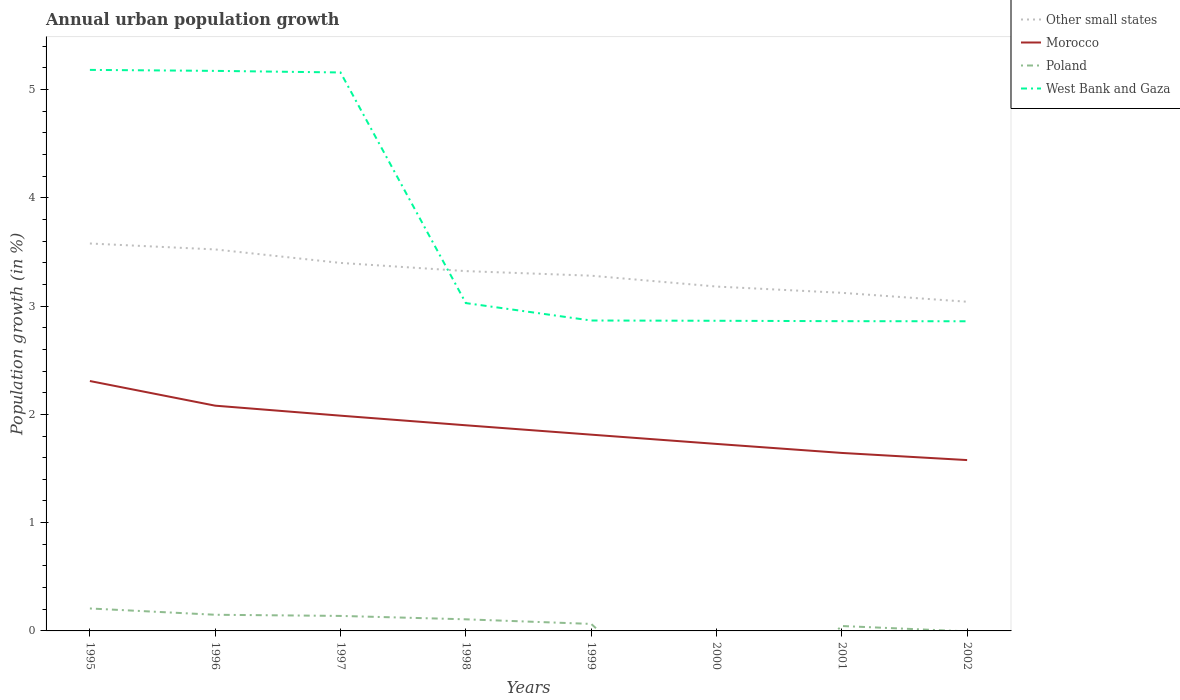Is the number of lines equal to the number of legend labels?
Keep it short and to the point. No. What is the total percentage of urban population growth in Morocco in the graph?
Your answer should be very brief. 0.26. What is the difference between the highest and the second highest percentage of urban population growth in Poland?
Provide a short and direct response. 0.21. Is the percentage of urban population growth in Poland strictly greater than the percentage of urban population growth in West Bank and Gaza over the years?
Keep it short and to the point. Yes. How many years are there in the graph?
Provide a succinct answer. 8. What is the difference between two consecutive major ticks on the Y-axis?
Your answer should be compact. 1. Are the values on the major ticks of Y-axis written in scientific E-notation?
Ensure brevity in your answer.  No. Does the graph contain any zero values?
Your answer should be compact. Yes. How many legend labels are there?
Your response must be concise. 4. How are the legend labels stacked?
Offer a very short reply. Vertical. What is the title of the graph?
Ensure brevity in your answer.  Annual urban population growth. Does "Argentina" appear as one of the legend labels in the graph?
Your response must be concise. No. What is the label or title of the Y-axis?
Give a very brief answer. Population growth (in %). What is the Population growth (in %) of Other small states in 1995?
Your answer should be compact. 3.58. What is the Population growth (in %) in Morocco in 1995?
Your answer should be compact. 2.31. What is the Population growth (in %) in Poland in 1995?
Provide a succinct answer. 0.21. What is the Population growth (in %) in West Bank and Gaza in 1995?
Give a very brief answer. 5.18. What is the Population growth (in %) of Other small states in 1996?
Your answer should be compact. 3.52. What is the Population growth (in %) of Morocco in 1996?
Keep it short and to the point. 2.08. What is the Population growth (in %) of Poland in 1996?
Keep it short and to the point. 0.15. What is the Population growth (in %) in West Bank and Gaza in 1996?
Offer a very short reply. 5.17. What is the Population growth (in %) of Other small states in 1997?
Provide a succinct answer. 3.4. What is the Population growth (in %) of Morocco in 1997?
Offer a very short reply. 1.99. What is the Population growth (in %) in Poland in 1997?
Make the answer very short. 0.14. What is the Population growth (in %) of West Bank and Gaza in 1997?
Your response must be concise. 5.16. What is the Population growth (in %) in Other small states in 1998?
Ensure brevity in your answer.  3.32. What is the Population growth (in %) of Morocco in 1998?
Keep it short and to the point. 1.9. What is the Population growth (in %) in Poland in 1998?
Offer a terse response. 0.11. What is the Population growth (in %) of West Bank and Gaza in 1998?
Your answer should be compact. 3.03. What is the Population growth (in %) in Other small states in 1999?
Provide a short and direct response. 3.28. What is the Population growth (in %) in Morocco in 1999?
Your answer should be compact. 1.81. What is the Population growth (in %) of Poland in 1999?
Your answer should be compact. 0.06. What is the Population growth (in %) of West Bank and Gaza in 1999?
Provide a succinct answer. 2.87. What is the Population growth (in %) of Other small states in 2000?
Offer a terse response. 3.18. What is the Population growth (in %) of Morocco in 2000?
Your response must be concise. 1.73. What is the Population growth (in %) of West Bank and Gaza in 2000?
Offer a very short reply. 2.86. What is the Population growth (in %) of Other small states in 2001?
Your answer should be very brief. 3.12. What is the Population growth (in %) in Morocco in 2001?
Provide a short and direct response. 1.64. What is the Population growth (in %) of Poland in 2001?
Make the answer very short. 0.05. What is the Population growth (in %) in West Bank and Gaza in 2001?
Keep it short and to the point. 2.86. What is the Population growth (in %) in Other small states in 2002?
Ensure brevity in your answer.  3.04. What is the Population growth (in %) of Morocco in 2002?
Offer a terse response. 1.58. What is the Population growth (in %) of West Bank and Gaza in 2002?
Offer a very short reply. 2.86. Across all years, what is the maximum Population growth (in %) in Other small states?
Provide a succinct answer. 3.58. Across all years, what is the maximum Population growth (in %) of Morocco?
Offer a very short reply. 2.31. Across all years, what is the maximum Population growth (in %) of Poland?
Your answer should be compact. 0.21. Across all years, what is the maximum Population growth (in %) in West Bank and Gaza?
Your response must be concise. 5.18. Across all years, what is the minimum Population growth (in %) of Other small states?
Your answer should be very brief. 3.04. Across all years, what is the minimum Population growth (in %) of Morocco?
Your answer should be compact. 1.58. Across all years, what is the minimum Population growth (in %) of Poland?
Your answer should be compact. 0. Across all years, what is the minimum Population growth (in %) in West Bank and Gaza?
Provide a short and direct response. 2.86. What is the total Population growth (in %) of Other small states in the graph?
Make the answer very short. 26.44. What is the total Population growth (in %) of Morocco in the graph?
Offer a terse response. 15.04. What is the total Population growth (in %) of Poland in the graph?
Offer a very short reply. 0.71. What is the total Population growth (in %) of West Bank and Gaza in the graph?
Your answer should be compact. 29.99. What is the difference between the Population growth (in %) of Other small states in 1995 and that in 1996?
Your answer should be very brief. 0.05. What is the difference between the Population growth (in %) of Morocco in 1995 and that in 1996?
Your response must be concise. 0.23. What is the difference between the Population growth (in %) in Poland in 1995 and that in 1996?
Give a very brief answer. 0.06. What is the difference between the Population growth (in %) in West Bank and Gaza in 1995 and that in 1996?
Ensure brevity in your answer.  0.01. What is the difference between the Population growth (in %) in Other small states in 1995 and that in 1997?
Ensure brevity in your answer.  0.18. What is the difference between the Population growth (in %) in Morocco in 1995 and that in 1997?
Make the answer very short. 0.32. What is the difference between the Population growth (in %) of Poland in 1995 and that in 1997?
Your response must be concise. 0.07. What is the difference between the Population growth (in %) in West Bank and Gaza in 1995 and that in 1997?
Offer a terse response. 0.02. What is the difference between the Population growth (in %) of Other small states in 1995 and that in 1998?
Ensure brevity in your answer.  0.25. What is the difference between the Population growth (in %) of Morocco in 1995 and that in 1998?
Your answer should be compact. 0.41. What is the difference between the Population growth (in %) of Poland in 1995 and that in 1998?
Provide a short and direct response. 0.1. What is the difference between the Population growth (in %) of West Bank and Gaza in 1995 and that in 1998?
Provide a short and direct response. 2.15. What is the difference between the Population growth (in %) in Other small states in 1995 and that in 1999?
Offer a very short reply. 0.3. What is the difference between the Population growth (in %) in Morocco in 1995 and that in 1999?
Offer a terse response. 0.5. What is the difference between the Population growth (in %) of Poland in 1995 and that in 1999?
Provide a succinct answer. 0.14. What is the difference between the Population growth (in %) in West Bank and Gaza in 1995 and that in 1999?
Keep it short and to the point. 2.31. What is the difference between the Population growth (in %) of Other small states in 1995 and that in 2000?
Offer a terse response. 0.4. What is the difference between the Population growth (in %) of Morocco in 1995 and that in 2000?
Make the answer very short. 0.58. What is the difference between the Population growth (in %) of West Bank and Gaza in 1995 and that in 2000?
Your answer should be very brief. 2.32. What is the difference between the Population growth (in %) of Other small states in 1995 and that in 2001?
Offer a terse response. 0.46. What is the difference between the Population growth (in %) of Morocco in 1995 and that in 2001?
Offer a terse response. 0.66. What is the difference between the Population growth (in %) of Poland in 1995 and that in 2001?
Keep it short and to the point. 0.16. What is the difference between the Population growth (in %) in West Bank and Gaza in 1995 and that in 2001?
Your answer should be very brief. 2.32. What is the difference between the Population growth (in %) of Other small states in 1995 and that in 2002?
Offer a terse response. 0.54. What is the difference between the Population growth (in %) of Morocco in 1995 and that in 2002?
Offer a very short reply. 0.73. What is the difference between the Population growth (in %) in West Bank and Gaza in 1995 and that in 2002?
Keep it short and to the point. 2.32. What is the difference between the Population growth (in %) of Other small states in 1996 and that in 1997?
Make the answer very short. 0.12. What is the difference between the Population growth (in %) of Morocco in 1996 and that in 1997?
Keep it short and to the point. 0.09. What is the difference between the Population growth (in %) in Poland in 1996 and that in 1997?
Give a very brief answer. 0.01. What is the difference between the Population growth (in %) of West Bank and Gaza in 1996 and that in 1997?
Offer a terse response. 0.01. What is the difference between the Population growth (in %) of Other small states in 1996 and that in 1998?
Give a very brief answer. 0.2. What is the difference between the Population growth (in %) in Morocco in 1996 and that in 1998?
Give a very brief answer. 0.18. What is the difference between the Population growth (in %) in Poland in 1996 and that in 1998?
Keep it short and to the point. 0.04. What is the difference between the Population growth (in %) of West Bank and Gaza in 1996 and that in 1998?
Provide a succinct answer. 2.14. What is the difference between the Population growth (in %) of Other small states in 1996 and that in 1999?
Offer a terse response. 0.24. What is the difference between the Population growth (in %) of Morocco in 1996 and that in 1999?
Ensure brevity in your answer.  0.27. What is the difference between the Population growth (in %) of Poland in 1996 and that in 1999?
Make the answer very short. 0.08. What is the difference between the Population growth (in %) of West Bank and Gaza in 1996 and that in 1999?
Keep it short and to the point. 2.31. What is the difference between the Population growth (in %) of Other small states in 1996 and that in 2000?
Your answer should be compact. 0.34. What is the difference between the Population growth (in %) of Morocco in 1996 and that in 2000?
Your response must be concise. 0.35. What is the difference between the Population growth (in %) in West Bank and Gaza in 1996 and that in 2000?
Offer a terse response. 2.31. What is the difference between the Population growth (in %) in Other small states in 1996 and that in 2001?
Your answer should be compact. 0.4. What is the difference between the Population growth (in %) of Morocco in 1996 and that in 2001?
Ensure brevity in your answer.  0.44. What is the difference between the Population growth (in %) of Poland in 1996 and that in 2001?
Provide a succinct answer. 0.1. What is the difference between the Population growth (in %) in West Bank and Gaza in 1996 and that in 2001?
Your answer should be compact. 2.31. What is the difference between the Population growth (in %) of Other small states in 1996 and that in 2002?
Offer a very short reply. 0.48. What is the difference between the Population growth (in %) of Morocco in 1996 and that in 2002?
Your answer should be compact. 0.5. What is the difference between the Population growth (in %) in West Bank and Gaza in 1996 and that in 2002?
Make the answer very short. 2.31. What is the difference between the Population growth (in %) of Other small states in 1997 and that in 1998?
Your answer should be compact. 0.08. What is the difference between the Population growth (in %) in Morocco in 1997 and that in 1998?
Offer a very short reply. 0.09. What is the difference between the Population growth (in %) in Poland in 1997 and that in 1998?
Give a very brief answer. 0.03. What is the difference between the Population growth (in %) in West Bank and Gaza in 1997 and that in 1998?
Provide a succinct answer. 2.13. What is the difference between the Population growth (in %) in Other small states in 1997 and that in 1999?
Provide a short and direct response. 0.12. What is the difference between the Population growth (in %) in Morocco in 1997 and that in 1999?
Your response must be concise. 0.18. What is the difference between the Population growth (in %) in Poland in 1997 and that in 1999?
Make the answer very short. 0.07. What is the difference between the Population growth (in %) in West Bank and Gaza in 1997 and that in 1999?
Give a very brief answer. 2.29. What is the difference between the Population growth (in %) in Other small states in 1997 and that in 2000?
Keep it short and to the point. 0.22. What is the difference between the Population growth (in %) in Morocco in 1997 and that in 2000?
Offer a terse response. 0.26. What is the difference between the Population growth (in %) in West Bank and Gaza in 1997 and that in 2000?
Your answer should be very brief. 2.29. What is the difference between the Population growth (in %) of Other small states in 1997 and that in 2001?
Ensure brevity in your answer.  0.28. What is the difference between the Population growth (in %) of Morocco in 1997 and that in 2001?
Ensure brevity in your answer.  0.34. What is the difference between the Population growth (in %) in Poland in 1997 and that in 2001?
Provide a short and direct response. 0.09. What is the difference between the Population growth (in %) in West Bank and Gaza in 1997 and that in 2001?
Your answer should be very brief. 2.3. What is the difference between the Population growth (in %) in Other small states in 1997 and that in 2002?
Provide a succinct answer. 0.36. What is the difference between the Population growth (in %) in Morocco in 1997 and that in 2002?
Your answer should be compact. 0.41. What is the difference between the Population growth (in %) in West Bank and Gaza in 1997 and that in 2002?
Make the answer very short. 2.3. What is the difference between the Population growth (in %) of Other small states in 1998 and that in 1999?
Make the answer very short. 0.04. What is the difference between the Population growth (in %) in Morocco in 1998 and that in 1999?
Provide a succinct answer. 0.09. What is the difference between the Population growth (in %) of Poland in 1998 and that in 1999?
Your answer should be compact. 0.04. What is the difference between the Population growth (in %) of West Bank and Gaza in 1998 and that in 1999?
Your answer should be very brief. 0.16. What is the difference between the Population growth (in %) of Other small states in 1998 and that in 2000?
Provide a succinct answer. 0.14. What is the difference between the Population growth (in %) of Morocco in 1998 and that in 2000?
Provide a succinct answer. 0.17. What is the difference between the Population growth (in %) of West Bank and Gaza in 1998 and that in 2000?
Your answer should be very brief. 0.16. What is the difference between the Population growth (in %) in Other small states in 1998 and that in 2001?
Offer a terse response. 0.2. What is the difference between the Population growth (in %) of Morocco in 1998 and that in 2001?
Offer a terse response. 0.26. What is the difference between the Population growth (in %) in Poland in 1998 and that in 2001?
Provide a succinct answer. 0.06. What is the difference between the Population growth (in %) of West Bank and Gaza in 1998 and that in 2001?
Offer a terse response. 0.17. What is the difference between the Population growth (in %) of Other small states in 1998 and that in 2002?
Provide a short and direct response. 0.28. What is the difference between the Population growth (in %) in Morocco in 1998 and that in 2002?
Keep it short and to the point. 0.32. What is the difference between the Population growth (in %) in West Bank and Gaza in 1998 and that in 2002?
Your answer should be compact. 0.17. What is the difference between the Population growth (in %) in Other small states in 1999 and that in 2000?
Keep it short and to the point. 0.1. What is the difference between the Population growth (in %) of Morocco in 1999 and that in 2000?
Your answer should be compact. 0.09. What is the difference between the Population growth (in %) of West Bank and Gaza in 1999 and that in 2000?
Give a very brief answer. 0. What is the difference between the Population growth (in %) of Other small states in 1999 and that in 2001?
Your answer should be very brief. 0.16. What is the difference between the Population growth (in %) of Morocco in 1999 and that in 2001?
Your response must be concise. 0.17. What is the difference between the Population growth (in %) in Poland in 1999 and that in 2001?
Your answer should be compact. 0.02. What is the difference between the Population growth (in %) in West Bank and Gaza in 1999 and that in 2001?
Offer a very short reply. 0.01. What is the difference between the Population growth (in %) in Other small states in 1999 and that in 2002?
Give a very brief answer. 0.24. What is the difference between the Population growth (in %) in Morocco in 1999 and that in 2002?
Offer a terse response. 0.23. What is the difference between the Population growth (in %) of West Bank and Gaza in 1999 and that in 2002?
Provide a short and direct response. 0.01. What is the difference between the Population growth (in %) in Other small states in 2000 and that in 2001?
Provide a short and direct response. 0.06. What is the difference between the Population growth (in %) of Morocco in 2000 and that in 2001?
Offer a very short reply. 0.08. What is the difference between the Population growth (in %) in West Bank and Gaza in 2000 and that in 2001?
Ensure brevity in your answer.  0. What is the difference between the Population growth (in %) in Other small states in 2000 and that in 2002?
Your response must be concise. 0.14. What is the difference between the Population growth (in %) of Morocco in 2000 and that in 2002?
Keep it short and to the point. 0.15. What is the difference between the Population growth (in %) of West Bank and Gaza in 2000 and that in 2002?
Ensure brevity in your answer.  0. What is the difference between the Population growth (in %) of Other small states in 2001 and that in 2002?
Make the answer very short. 0.08. What is the difference between the Population growth (in %) in Morocco in 2001 and that in 2002?
Your response must be concise. 0.07. What is the difference between the Population growth (in %) in West Bank and Gaza in 2001 and that in 2002?
Your answer should be very brief. 0. What is the difference between the Population growth (in %) in Other small states in 1995 and the Population growth (in %) in Morocco in 1996?
Give a very brief answer. 1.5. What is the difference between the Population growth (in %) of Other small states in 1995 and the Population growth (in %) of Poland in 1996?
Your response must be concise. 3.43. What is the difference between the Population growth (in %) in Other small states in 1995 and the Population growth (in %) in West Bank and Gaza in 1996?
Give a very brief answer. -1.59. What is the difference between the Population growth (in %) of Morocco in 1995 and the Population growth (in %) of Poland in 1996?
Keep it short and to the point. 2.16. What is the difference between the Population growth (in %) in Morocco in 1995 and the Population growth (in %) in West Bank and Gaza in 1996?
Offer a very short reply. -2.86. What is the difference between the Population growth (in %) of Poland in 1995 and the Population growth (in %) of West Bank and Gaza in 1996?
Offer a terse response. -4.96. What is the difference between the Population growth (in %) in Other small states in 1995 and the Population growth (in %) in Morocco in 1997?
Keep it short and to the point. 1.59. What is the difference between the Population growth (in %) of Other small states in 1995 and the Population growth (in %) of Poland in 1997?
Offer a terse response. 3.44. What is the difference between the Population growth (in %) of Other small states in 1995 and the Population growth (in %) of West Bank and Gaza in 1997?
Ensure brevity in your answer.  -1.58. What is the difference between the Population growth (in %) in Morocco in 1995 and the Population growth (in %) in Poland in 1997?
Your answer should be very brief. 2.17. What is the difference between the Population growth (in %) of Morocco in 1995 and the Population growth (in %) of West Bank and Gaza in 1997?
Provide a short and direct response. -2.85. What is the difference between the Population growth (in %) of Poland in 1995 and the Population growth (in %) of West Bank and Gaza in 1997?
Provide a short and direct response. -4.95. What is the difference between the Population growth (in %) of Other small states in 1995 and the Population growth (in %) of Morocco in 1998?
Give a very brief answer. 1.68. What is the difference between the Population growth (in %) of Other small states in 1995 and the Population growth (in %) of Poland in 1998?
Your answer should be compact. 3.47. What is the difference between the Population growth (in %) in Other small states in 1995 and the Population growth (in %) in West Bank and Gaza in 1998?
Your answer should be compact. 0.55. What is the difference between the Population growth (in %) of Morocco in 1995 and the Population growth (in %) of Poland in 1998?
Offer a terse response. 2.2. What is the difference between the Population growth (in %) of Morocco in 1995 and the Population growth (in %) of West Bank and Gaza in 1998?
Offer a terse response. -0.72. What is the difference between the Population growth (in %) of Poland in 1995 and the Population growth (in %) of West Bank and Gaza in 1998?
Make the answer very short. -2.82. What is the difference between the Population growth (in %) in Other small states in 1995 and the Population growth (in %) in Morocco in 1999?
Offer a terse response. 1.77. What is the difference between the Population growth (in %) in Other small states in 1995 and the Population growth (in %) in Poland in 1999?
Your response must be concise. 3.51. What is the difference between the Population growth (in %) in Other small states in 1995 and the Population growth (in %) in West Bank and Gaza in 1999?
Provide a short and direct response. 0.71. What is the difference between the Population growth (in %) of Morocco in 1995 and the Population growth (in %) of Poland in 1999?
Give a very brief answer. 2.24. What is the difference between the Population growth (in %) of Morocco in 1995 and the Population growth (in %) of West Bank and Gaza in 1999?
Give a very brief answer. -0.56. What is the difference between the Population growth (in %) of Poland in 1995 and the Population growth (in %) of West Bank and Gaza in 1999?
Ensure brevity in your answer.  -2.66. What is the difference between the Population growth (in %) of Other small states in 1995 and the Population growth (in %) of Morocco in 2000?
Your answer should be very brief. 1.85. What is the difference between the Population growth (in %) of Other small states in 1995 and the Population growth (in %) of West Bank and Gaza in 2000?
Offer a very short reply. 0.71. What is the difference between the Population growth (in %) of Morocco in 1995 and the Population growth (in %) of West Bank and Gaza in 2000?
Provide a short and direct response. -0.56. What is the difference between the Population growth (in %) of Poland in 1995 and the Population growth (in %) of West Bank and Gaza in 2000?
Ensure brevity in your answer.  -2.66. What is the difference between the Population growth (in %) of Other small states in 1995 and the Population growth (in %) of Morocco in 2001?
Your response must be concise. 1.93. What is the difference between the Population growth (in %) of Other small states in 1995 and the Population growth (in %) of Poland in 2001?
Make the answer very short. 3.53. What is the difference between the Population growth (in %) of Other small states in 1995 and the Population growth (in %) of West Bank and Gaza in 2001?
Offer a terse response. 0.72. What is the difference between the Population growth (in %) of Morocco in 1995 and the Population growth (in %) of Poland in 2001?
Offer a very short reply. 2.26. What is the difference between the Population growth (in %) of Morocco in 1995 and the Population growth (in %) of West Bank and Gaza in 2001?
Your answer should be very brief. -0.55. What is the difference between the Population growth (in %) in Poland in 1995 and the Population growth (in %) in West Bank and Gaza in 2001?
Your answer should be compact. -2.65. What is the difference between the Population growth (in %) of Other small states in 1995 and the Population growth (in %) of Morocco in 2002?
Provide a short and direct response. 2. What is the difference between the Population growth (in %) of Other small states in 1995 and the Population growth (in %) of West Bank and Gaza in 2002?
Your answer should be compact. 0.72. What is the difference between the Population growth (in %) in Morocco in 1995 and the Population growth (in %) in West Bank and Gaza in 2002?
Offer a very short reply. -0.55. What is the difference between the Population growth (in %) in Poland in 1995 and the Population growth (in %) in West Bank and Gaza in 2002?
Give a very brief answer. -2.65. What is the difference between the Population growth (in %) in Other small states in 1996 and the Population growth (in %) in Morocco in 1997?
Your answer should be compact. 1.54. What is the difference between the Population growth (in %) of Other small states in 1996 and the Population growth (in %) of Poland in 1997?
Give a very brief answer. 3.38. What is the difference between the Population growth (in %) of Other small states in 1996 and the Population growth (in %) of West Bank and Gaza in 1997?
Give a very brief answer. -1.63. What is the difference between the Population growth (in %) of Morocco in 1996 and the Population growth (in %) of Poland in 1997?
Provide a short and direct response. 1.94. What is the difference between the Population growth (in %) in Morocco in 1996 and the Population growth (in %) in West Bank and Gaza in 1997?
Ensure brevity in your answer.  -3.08. What is the difference between the Population growth (in %) in Poland in 1996 and the Population growth (in %) in West Bank and Gaza in 1997?
Offer a very short reply. -5.01. What is the difference between the Population growth (in %) of Other small states in 1996 and the Population growth (in %) of Morocco in 1998?
Your answer should be compact. 1.62. What is the difference between the Population growth (in %) of Other small states in 1996 and the Population growth (in %) of Poland in 1998?
Ensure brevity in your answer.  3.42. What is the difference between the Population growth (in %) in Other small states in 1996 and the Population growth (in %) in West Bank and Gaza in 1998?
Keep it short and to the point. 0.5. What is the difference between the Population growth (in %) in Morocco in 1996 and the Population growth (in %) in Poland in 1998?
Offer a terse response. 1.97. What is the difference between the Population growth (in %) in Morocco in 1996 and the Population growth (in %) in West Bank and Gaza in 1998?
Offer a very short reply. -0.95. What is the difference between the Population growth (in %) in Poland in 1996 and the Population growth (in %) in West Bank and Gaza in 1998?
Give a very brief answer. -2.88. What is the difference between the Population growth (in %) of Other small states in 1996 and the Population growth (in %) of Morocco in 1999?
Provide a short and direct response. 1.71. What is the difference between the Population growth (in %) of Other small states in 1996 and the Population growth (in %) of Poland in 1999?
Give a very brief answer. 3.46. What is the difference between the Population growth (in %) of Other small states in 1996 and the Population growth (in %) of West Bank and Gaza in 1999?
Give a very brief answer. 0.66. What is the difference between the Population growth (in %) in Morocco in 1996 and the Population growth (in %) in Poland in 1999?
Make the answer very short. 2.02. What is the difference between the Population growth (in %) of Morocco in 1996 and the Population growth (in %) of West Bank and Gaza in 1999?
Provide a short and direct response. -0.79. What is the difference between the Population growth (in %) in Poland in 1996 and the Population growth (in %) in West Bank and Gaza in 1999?
Provide a short and direct response. -2.72. What is the difference between the Population growth (in %) of Other small states in 1996 and the Population growth (in %) of Morocco in 2000?
Ensure brevity in your answer.  1.8. What is the difference between the Population growth (in %) of Other small states in 1996 and the Population growth (in %) of West Bank and Gaza in 2000?
Ensure brevity in your answer.  0.66. What is the difference between the Population growth (in %) in Morocco in 1996 and the Population growth (in %) in West Bank and Gaza in 2000?
Your answer should be very brief. -0.78. What is the difference between the Population growth (in %) of Poland in 1996 and the Population growth (in %) of West Bank and Gaza in 2000?
Make the answer very short. -2.71. What is the difference between the Population growth (in %) of Other small states in 1996 and the Population growth (in %) of Morocco in 2001?
Make the answer very short. 1.88. What is the difference between the Population growth (in %) in Other small states in 1996 and the Population growth (in %) in Poland in 2001?
Provide a succinct answer. 3.48. What is the difference between the Population growth (in %) of Other small states in 1996 and the Population growth (in %) of West Bank and Gaza in 2001?
Offer a very short reply. 0.66. What is the difference between the Population growth (in %) in Morocco in 1996 and the Population growth (in %) in Poland in 2001?
Your answer should be compact. 2.03. What is the difference between the Population growth (in %) of Morocco in 1996 and the Population growth (in %) of West Bank and Gaza in 2001?
Offer a terse response. -0.78. What is the difference between the Population growth (in %) of Poland in 1996 and the Population growth (in %) of West Bank and Gaza in 2001?
Make the answer very short. -2.71. What is the difference between the Population growth (in %) of Other small states in 1996 and the Population growth (in %) of Morocco in 2002?
Make the answer very short. 1.95. What is the difference between the Population growth (in %) in Other small states in 1996 and the Population growth (in %) in West Bank and Gaza in 2002?
Offer a very short reply. 0.66. What is the difference between the Population growth (in %) of Morocco in 1996 and the Population growth (in %) of West Bank and Gaza in 2002?
Make the answer very short. -0.78. What is the difference between the Population growth (in %) in Poland in 1996 and the Population growth (in %) in West Bank and Gaza in 2002?
Make the answer very short. -2.71. What is the difference between the Population growth (in %) in Other small states in 1997 and the Population growth (in %) in Morocco in 1998?
Provide a succinct answer. 1.5. What is the difference between the Population growth (in %) in Other small states in 1997 and the Population growth (in %) in Poland in 1998?
Offer a very short reply. 3.29. What is the difference between the Population growth (in %) of Other small states in 1997 and the Population growth (in %) of West Bank and Gaza in 1998?
Provide a succinct answer. 0.37. What is the difference between the Population growth (in %) in Morocco in 1997 and the Population growth (in %) in Poland in 1998?
Your answer should be compact. 1.88. What is the difference between the Population growth (in %) in Morocco in 1997 and the Population growth (in %) in West Bank and Gaza in 1998?
Offer a terse response. -1.04. What is the difference between the Population growth (in %) in Poland in 1997 and the Population growth (in %) in West Bank and Gaza in 1998?
Ensure brevity in your answer.  -2.89. What is the difference between the Population growth (in %) in Other small states in 1997 and the Population growth (in %) in Morocco in 1999?
Ensure brevity in your answer.  1.59. What is the difference between the Population growth (in %) of Other small states in 1997 and the Population growth (in %) of Poland in 1999?
Provide a short and direct response. 3.33. What is the difference between the Population growth (in %) of Other small states in 1997 and the Population growth (in %) of West Bank and Gaza in 1999?
Ensure brevity in your answer.  0.53. What is the difference between the Population growth (in %) in Morocco in 1997 and the Population growth (in %) in Poland in 1999?
Give a very brief answer. 1.92. What is the difference between the Population growth (in %) of Morocco in 1997 and the Population growth (in %) of West Bank and Gaza in 1999?
Provide a short and direct response. -0.88. What is the difference between the Population growth (in %) in Poland in 1997 and the Population growth (in %) in West Bank and Gaza in 1999?
Ensure brevity in your answer.  -2.73. What is the difference between the Population growth (in %) of Other small states in 1997 and the Population growth (in %) of Morocco in 2000?
Your answer should be very brief. 1.67. What is the difference between the Population growth (in %) of Other small states in 1997 and the Population growth (in %) of West Bank and Gaza in 2000?
Offer a very short reply. 0.53. What is the difference between the Population growth (in %) of Morocco in 1997 and the Population growth (in %) of West Bank and Gaza in 2000?
Ensure brevity in your answer.  -0.88. What is the difference between the Population growth (in %) of Poland in 1997 and the Population growth (in %) of West Bank and Gaza in 2000?
Offer a terse response. -2.73. What is the difference between the Population growth (in %) of Other small states in 1997 and the Population growth (in %) of Morocco in 2001?
Keep it short and to the point. 1.75. What is the difference between the Population growth (in %) of Other small states in 1997 and the Population growth (in %) of Poland in 2001?
Ensure brevity in your answer.  3.35. What is the difference between the Population growth (in %) in Other small states in 1997 and the Population growth (in %) in West Bank and Gaza in 2001?
Ensure brevity in your answer.  0.54. What is the difference between the Population growth (in %) in Morocco in 1997 and the Population growth (in %) in Poland in 2001?
Offer a very short reply. 1.94. What is the difference between the Population growth (in %) in Morocco in 1997 and the Population growth (in %) in West Bank and Gaza in 2001?
Offer a very short reply. -0.87. What is the difference between the Population growth (in %) of Poland in 1997 and the Population growth (in %) of West Bank and Gaza in 2001?
Ensure brevity in your answer.  -2.72. What is the difference between the Population growth (in %) in Other small states in 1997 and the Population growth (in %) in Morocco in 2002?
Your answer should be very brief. 1.82. What is the difference between the Population growth (in %) in Other small states in 1997 and the Population growth (in %) in West Bank and Gaza in 2002?
Your answer should be very brief. 0.54. What is the difference between the Population growth (in %) in Morocco in 1997 and the Population growth (in %) in West Bank and Gaza in 2002?
Offer a terse response. -0.87. What is the difference between the Population growth (in %) of Poland in 1997 and the Population growth (in %) of West Bank and Gaza in 2002?
Ensure brevity in your answer.  -2.72. What is the difference between the Population growth (in %) of Other small states in 1998 and the Population growth (in %) of Morocco in 1999?
Ensure brevity in your answer.  1.51. What is the difference between the Population growth (in %) in Other small states in 1998 and the Population growth (in %) in Poland in 1999?
Provide a short and direct response. 3.26. What is the difference between the Population growth (in %) in Other small states in 1998 and the Population growth (in %) in West Bank and Gaza in 1999?
Offer a very short reply. 0.46. What is the difference between the Population growth (in %) in Morocco in 1998 and the Population growth (in %) in Poland in 1999?
Your response must be concise. 1.83. What is the difference between the Population growth (in %) in Morocco in 1998 and the Population growth (in %) in West Bank and Gaza in 1999?
Make the answer very short. -0.97. What is the difference between the Population growth (in %) of Poland in 1998 and the Population growth (in %) of West Bank and Gaza in 1999?
Make the answer very short. -2.76. What is the difference between the Population growth (in %) in Other small states in 1998 and the Population growth (in %) in Morocco in 2000?
Offer a very short reply. 1.6. What is the difference between the Population growth (in %) of Other small states in 1998 and the Population growth (in %) of West Bank and Gaza in 2000?
Ensure brevity in your answer.  0.46. What is the difference between the Population growth (in %) in Morocco in 1998 and the Population growth (in %) in West Bank and Gaza in 2000?
Provide a short and direct response. -0.97. What is the difference between the Population growth (in %) of Poland in 1998 and the Population growth (in %) of West Bank and Gaza in 2000?
Offer a very short reply. -2.76. What is the difference between the Population growth (in %) in Other small states in 1998 and the Population growth (in %) in Morocco in 2001?
Ensure brevity in your answer.  1.68. What is the difference between the Population growth (in %) in Other small states in 1998 and the Population growth (in %) in Poland in 2001?
Make the answer very short. 3.28. What is the difference between the Population growth (in %) of Other small states in 1998 and the Population growth (in %) of West Bank and Gaza in 2001?
Your answer should be very brief. 0.46. What is the difference between the Population growth (in %) of Morocco in 1998 and the Population growth (in %) of Poland in 2001?
Give a very brief answer. 1.85. What is the difference between the Population growth (in %) of Morocco in 1998 and the Population growth (in %) of West Bank and Gaza in 2001?
Offer a terse response. -0.96. What is the difference between the Population growth (in %) of Poland in 1998 and the Population growth (in %) of West Bank and Gaza in 2001?
Provide a succinct answer. -2.75. What is the difference between the Population growth (in %) in Other small states in 1998 and the Population growth (in %) in Morocco in 2002?
Provide a short and direct response. 1.75. What is the difference between the Population growth (in %) of Other small states in 1998 and the Population growth (in %) of West Bank and Gaza in 2002?
Make the answer very short. 0.46. What is the difference between the Population growth (in %) of Morocco in 1998 and the Population growth (in %) of West Bank and Gaza in 2002?
Keep it short and to the point. -0.96. What is the difference between the Population growth (in %) in Poland in 1998 and the Population growth (in %) in West Bank and Gaza in 2002?
Your answer should be very brief. -2.75. What is the difference between the Population growth (in %) in Other small states in 1999 and the Population growth (in %) in Morocco in 2000?
Offer a terse response. 1.55. What is the difference between the Population growth (in %) of Other small states in 1999 and the Population growth (in %) of West Bank and Gaza in 2000?
Offer a very short reply. 0.42. What is the difference between the Population growth (in %) in Morocco in 1999 and the Population growth (in %) in West Bank and Gaza in 2000?
Provide a short and direct response. -1.05. What is the difference between the Population growth (in %) of Poland in 1999 and the Population growth (in %) of West Bank and Gaza in 2000?
Your answer should be very brief. -2.8. What is the difference between the Population growth (in %) in Other small states in 1999 and the Population growth (in %) in Morocco in 2001?
Offer a very short reply. 1.64. What is the difference between the Population growth (in %) in Other small states in 1999 and the Population growth (in %) in Poland in 2001?
Keep it short and to the point. 3.24. What is the difference between the Population growth (in %) of Other small states in 1999 and the Population growth (in %) of West Bank and Gaza in 2001?
Make the answer very short. 0.42. What is the difference between the Population growth (in %) in Morocco in 1999 and the Population growth (in %) in Poland in 2001?
Your answer should be compact. 1.77. What is the difference between the Population growth (in %) of Morocco in 1999 and the Population growth (in %) of West Bank and Gaza in 2001?
Provide a succinct answer. -1.05. What is the difference between the Population growth (in %) of Poland in 1999 and the Population growth (in %) of West Bank and Gaza in 2001?
Your response must be concise. -2.8. What is the difference between the Population growth (in %) of Other small states in 1999 and the Population growth (in %) of Morocco in 2002?
Give a very brief answer. 1.7. What is the difference between the Population growth (in %) in Other small states in 1999 and the Population growth (in %) in West Bank and Gaza in 2002?
Give a very brief answer. 0.42. What is the difference between the Population growth (in %) in Morocco in 1999 and the Population growth (in %) in West Bank and Gaza in 2002?
Provide a succinct answer. -1.05. What is the difference between the Population growth (in %) of Poland in 1999 and the Population growth (in %) of West Bank and Gaza in 2002?
Offer a very short reply. -2.79. What is the difference between the Population growth (in %) in Other small states in 2000 and the Population growth (in %) in Morocco in 2001?
Make the answer very short. 1.54. What is the difference between the Population growth (in %) in Other small states in 2000 and the Population growth (in %) in Poland in 2001?
Provide a succinct answer. 3.13. What is the difference between the Population growth (in %) in Other small states in 2000 and the Population growth (in %) in West Bank and Gaza in 2001?
Make the answer very short. 0.32. What is the difference between the Population growth (in %) in Morocco in 2000 and the Population growth (in %) in Poland in 2001?
Offer a very short reply. 1.68. What is the difference between the Population growth (in %) of Morocco in 2000 and the Population growth (in %) of West Bank and Gaza in 2001?
Your answer should be compact. -1.13. What is the difference between the Population growth (in %) of Other small states in 2000 and the Population growth (in %) of Morocco in 2002?
Your answer should be very brief. 1.6. What is the difference between the Population growth (in %) in Other small states in 2000 and the Population growth (in %) in West Bank and Gaza in 2002?
Ensure brevity in your answer.  0.32. What is the difference between the Population growth (in %) in Morocco in 2000 and the Population growth (in %) in West Bank and Gaza in 2002?
Ensure brevity in your answer.  -1.13. What is the difference between the Population growth (in %) in Other small states in 2001 and the Population growth (in %) in Morocco in 2002?
Keep it short and to the point. 1.54. What is the difference between the Population growth (in %) of Other small states in 2001 and the Population growth (in %) of West Bank and Gaza in 2002?
Ensure brevity in your answer.  0.26. What is the difference between the Population growth (in %) of Morocco in 2001 and the Population growth (in %) of West Bank and Gaza in 2002?
Ensure brevity in your answer.  -1.22. What is the difference between the Population growth (in %) in Poland in 2001 and the Population growth (in %) in West Bank and Gaza in 2002?
Ensure brevity in your answer.  -2.81. What is the average Population growth (in %) of Other small states per year?
Your answer should be compact. 3.31. What is the average Population growth (in %) in Morocco per year?
Your response must be concise. 1.88. What is the average Population growth (in %) of Poland per year?
Your response must be concise. 0.09. What is the average Population growth (in %) in West Bank and Gaza per year?
Your answer should be very brief. 3.75. In the year 1995, what is the difference between the Population growth (in %) of Other small states and Population growth (in %) of Morocco?
Keep it short and to the point. 1.27. In the year 1995, what is the difference between the Population growth (in %) in Other small states and Population growth (in %) in Poland?
Ensure brevity in your answer.  3.37. In the year 1995, what is the difference between the Population growth (in %) in Other small states and Population growth (in %) in West Bank and Gaza?
Make the answer very short. -1.6. In the year 1995, what is the difference between the Population growth (in %) in Morocco and Population growth (in %) in Poland?
Your answer should be very brief. 2.1. In the year 1995, what is the difference between the Population growth (in %) in Morocco and Population growth (in %) in West Bank and Gaza?
Provide a short and direct response. -2.87. In the year 1995, what is the difference between the Population growth (in %) in Poland and Population growth (in %) in West Bank and Gaza?
Ensure brevity in your answer.  -4.97. In the year 1996, what is the difference between the Population growth (in %) of Other small states and Population growth (in %) of Morocco?
Give a very brief answer. 1.44. In the year 1996, what is the difference between the Population growth (in %) in Other small states and Population growth (in %) in Poland?
Keep it short and to the point. 3.37. In the year 1996, what is the difference between the Population growth (in %) of Other small states and Population growth (in %) of West Bank and Gaza?
Your answer should be very brief. -1.65. In the year 1996, what is the difference between the Population growth (in %) in Morocco and Population growth (in %) in Poland?
Make the answer very short. 1.93. In the year 1996, what is the difference between the Population growth (in %) of Morocco and Population growth (in %) of West Bank and Gaza?
Provide a succinct answer. -3.09. In the year 1996, what is the difference between the Population growth (in %) in Poland and Population growth (in %) in West Bank and Gaza?
Provide a succinct answer. -5.02. In the year 1997, what is the difference between the Population growth (in %) of Other small states and Population growth (in %) of Morocco?
Your answer should be compact. 1.41. In the year 1997, what is the difference between the Population growth (in %) of Other small states and Population growth (in %) of Poland?
Ensure brevity in your answer.  3.26. In the year 1997, what is the difference between the Population growth (in %) of Other small states and Population growth (in %) of West Bank and Gaza?
Your response must be concise. -1.76. In the year 1997, what is the difference between the Population growth (in %) of Morocco and Population growth (in %) of Poland?
Offer a terse response. 1.85. In the year 1997, what is the difference between the Population growth (in %) of Morocco and Population growth (in %) of West Bank and Gaza?
Give a very brief answer. -3.17. In the year 1997, what is the difference between the Population growth (in %) of Poland and Population growth (in %) of West Bank and Gaza?
Provide a short and direct response. -5.02. In the year 1998, what is the difference between the Population growth (in %) in Other small states and Population growth (in %) in Morocco?
Provide a succinct answer. 1.42. In the year 1998, what is the difference between the Population growth (in %) of Other small states and Population growth (in %) of Poland?
Your response must be concise. 3.22. In the year 1998, what is the difference between the Population growth (in %) in Other small states and Population growth (in %) in West Bank and Gaza?
Provide a short and direct response. 0.3. In the year 1998, what is the difference between the Population growth (in %) in Morocco and Population growth (in %) in Poland?
Provide a short and direct response. 1.79. In the year 1998, what is the difference between the Population growth (in %) of Morocco and Population growth (in %) of West Bank and Gaza?
Keep it short and to the point. -1.13. In the year 1998, what is the difference between the Population growth (in %) of Poland and Population growth (in %) of West Bank and Gaza?
Ensure brevity in your answer.  -2.92. In the year 1999, what is the difference between the Population growth (in %) in Other small states and Population growth (in %) in Morocco?
Your answer should be very brief. 1.47. In the year 1999, what is the difference between the Population growth (in %) in Other small states and Population growth (in %) in Poland?
Provide a succinct answer. 3.22. In the year 1999, what is the difference between the Population growth (in %) in Other small states and Population growth (in %) in West Bank and Gaza?
Your response must be concise. 0.41. In the year 1999, what is the difference between the Population growth (in %) in Morocco and Population growth (in %) in Poland?
Ensure brevity in your answer.  1.75. In the year 1999, what is the difference between the Population growth (in %) of Morocco and Population growth (in %) of West Bank and Gaza?
Your answer should be compact. -1.05. In the year 1999, what is the difference between the Population growth (in %) of Poland and Population growth (in %) of West Bank and Gaza?
Your answer should be very brief. -2.8. In the year 2000, what is the difference between the Population growth (in %) of Other small states and Population growth (in %) of Morocco?
Give a very brief answer. 1.45. In the year 2000, what is the difference between the Population growth (in %) of Other small states and Population growth (in %) of West Bank and Gaza?
Give a very brief answer. 0.32. In the year 2000, what is the difference between the Population growth (in %) in Morocco and Population growth (in %) in West Bank and Gaza?
Provide a short and direct response. -1.14. In the year 2001, what is the difference between the Population growth (in %) of Other small states and Population growth (in %) of Morocco?
Your response must be concise. 1.48. In the year 2001, what is the difference between the Population growth (in %) in Other small states and Population growth (in %) in Poland?
Provide a short and direct response. 3.08. In the year 2001, what is the difference between the Population growth (in %) in Other small states and Population growth (in %) in West Bank and Gaza?
Offer a very short reply. 0.26. In the year 2001, what is the difference between the Population growth (in %) in Morocco and Population growth (in %) in Poland?
Provide a short and direct response. 1.6. In the year 2001, what is the difference between the Population growth (in %) in Morocco and Population growth (in %) in West Bank and Gaza?
Your answer should be very brief. -1.22. In the year 2001, what is the difference between the Population growth (in %) of Poland and Population growth (in %) of West Bank and Gaza?
Provide a succinct answer. -2.82. In the year 2002, what is the difference between the Population growth (in %) in Other small states and Population growth (in %) in Morocco?
Your answer should be compact. 1.46. In the year 2002, what is the difference between the Population growth (in %) in Other small states and Population growth (in %) in West Bank and Gaza?
Offer a very short reply. 0.18. In the year 2002, what is the difference between the Population growth (in %) of Morocco and Population growth (in %) of West Bank and Gaza?
Offer a terse response. -1.28. What is the ratio of the Population growth (in %) in Other small states in 1995 to that in 1996?
Ensure brevity in your answer.  1.02. What is the ratio of the Population growth (in %) in Morocco in 1995 to that in 1996?
Offer a very short reply. 1.11. What is the ratio of the Population growth (in %) in Poland in 1995 to that in 1996?
Give a very brief answer. 1.39. What is the ratio of the Population growth (in %) in West Bank and Gaza in 1995 to that in 1996?
Offer a terse response. 1. What is the ratio of the Population growth (in %) of Other small states in 1995 to that in 1997?
Make the answer very short. 1.05. What is the ratio of the Population growth (in %) of Morocco in 1995 to that in 1997?
Give a very brief answer. 1.16. What is the ratio of the Population growth (in %) in Poland in 1995 to that in 1997?
Your answer should be very brief. 1.5. What is the ratio of the Population growth (in %) in West Bank and Gaza in 1995 to that in 1997?
Keep it short and to the point. 1. What is the ratio of the Population growth (in %) of Other small states in 1995 to that in 1998?
Provide a succinct answer. 1.08. What is the ratio of the Population growth (in %) of Morocco in 1995 to that in 1998?
Provide a succinct answer. 1.22. What is the ratio of the Population growth (in %) of Poland in 1995 to that in 1998?
Your answer should be very brief. 1.93. What is the ratio of the Population growth (in %) of West Bank and Gaza in 1995 to that in 1998?
Provide a short and direct response. 1.71. What is the ratio of the Population growth (in %) of Other small states in 1995 to that in 1999?
Provide a short and direct response. 1.09. What is the ratio of the Population growth (in %) of Morocco in 1995 to that in 1999?
Your answer should be compact. 1.27. What is the ratio of the Population growth (in %) in Poland in 1995 to that in 1999?
Give a very brief answer. 3.2. What is the ratio of the Population growth (in %) of West Bank and Gaza in 1995 to that in 1999?
Ensure brevity in your answer.  1.81. What is the ratio of the Population growth (in %) of Morocco in 1995 to that in 2000?
Offer a terse response. 1.34. What is the ratio of the Population growth (in %) in West Bank and Gaza in 1995 to that in 2000?
Your answer should be compact. 1.81. What is the ratio of the Population growth (in %) of Other small states in 1995 to that in 2001?
Make the answer very short. 1.15. What is the ratio of the Population growth (in %) of Morocco in 1995 to that in 2001?
Your response must be concise. 1.4. What is the ratio of the Population growth (in %) of Poland in 1995 to that in 2001?
Your response must be concise. 4.58. What is the ratio of the Population growth (in %) in West Bank and Gaza in 1995 to that in 2001?
Keep it short and to the point. 1.81. What is the ratio of the Population growth (in %) of Other small states in 1995 to that in 2002?
Ensure brevity in your answer.  1.18. What is the ratio of the Population growth (in %) in Morocco in 1995 to that in 2002?
Keep it short and to the point. 1.46. What is the ratio of the Population growth (in %) of West Bank and Gaza in 1995 to that in 2002?
Provide a short and direct response. 1.81. What is the ratio of the Population growth (in %) in Other small states in 1996 to that in 1997?
Offer a very short reply. 1.04. What is the ratio of the Population growth (in %) in Morocco in 1996 to that in 1997?
Offer a terse response. 1.05. What is the ratio of the Population growth (in %) of Poland in 1996 to that in 1997?
Make the answer very short. 1.08. What is the ratio of the Population growth (in %) of West Bank and Gaza in 1996 to that in 1997?
Ensure brevity in your answer.  1. What is the ratio of the Population growth (in %) of Other small states in 1996 to that in 1998?
Offer a very short reply. 1.06. What is the ratio of the Population growth (in %) of Morocco in 1996 to that in 1998?
Give a very brief answer. 1.1. What is the ratio of the Population growth (in %) in Poland in 1996 to that in 1998?
Your answer should be compact. 1.39. What is the ratio of the Population growth (in %) in West Bank and Gaza in 1996 to that in 1998?
Give a very brief answer. 1.71. What is the ratio of the Population growth (in %) of Other small states in 1996 to that in 1999?
Your answer should be compact. 1.07. What is the ratio of the Population growth (in %) of Morocco in 1996 to that in 1999?
Offer a terse response. 1.15. What is the ratio of the Population growth (in %) in Poland in 1996 to that in 1999?
Offer a terse response. 2.31. What is the ratio of the Population growth (in %) of West Bank and Gaza in 1996 to that in 1999?
Your response must be concise. 1.8. What is the ratio of the Population growth (in %) of Other small states in 1996 to that in 2000?
Your answer should be very brief. 1.11. What is the ratio of the Population growth (in %) of Morocco in 1996 to that in 2000?
Keep it short and to the point. 1.2. What is the ratio of the Population growth (in %) of West Bank and Gaza in 1996 to that in 2000?
Provide a succinct answer. 1.81. What is the ratio of the Population growth (in %) of Other small states in 1996 to that in 2001?
Provide a short and direct response. 1.13. What is the ratio of the Population growth (in %) of Morocco in 1996 to that in 2001?
Ensure brevity in your answer.  1.27. What is the ratio of the Population growth (in %) in Poland in 1996 to that in 2001?
Offer a very short reply. 3.29. What is the ratio of the Population growth (in %) of West Bank and Gaza in 1996 to that in 2001?
Your answer should be compact. 1.81. What is the ratio of the Population growth (in %) of Other small states in 1996 to that in 2002?
Offer a terse response. 1.16. What is the ratio of the Population growth (in %) in Morocco in 1996 to that in 2002?
Your answer should be very brief. 1.32. What is the ratio of the Population growth (in %) in West Bank and Gaza in 1996 to that in 2002?
Your answer should be very brief. 1.81. What is the ratio of the Population growth (in %) of Other small states in 1997 to that in 1998?
Give a very brief answer. 1.02. What is the ratio of the Population growth (in %) of Morocco in 1997 to that in 1998?
Offer a terse response. 1.05. What is the ratio of the Population growth (in %) of Poland in 1997 to that in 1998?
Provide a succinct answer. 1.29. What is the ratio of the Population growth (in %) in West Bank and Gaza in 1997 to that in 1998?
Offer a terse response. 1.7. What is the ratio of the Population growth (in %) of Other small states in 1997 to that in 1999?
Your answer should be very brief. 1.04. What is the ratio of the Population growth (in %) of Morocco in 1997 to that in 1999?
Give a very brief answer. 1.1. What is the ratio of the Population growth (in %) of Poland in 1997 to that in 1999?
Your answer should be very brief. 2.14. What is the ratio of the Population growth (in %) in West Bank and Gaza in 1997 to that in 1999?
Give a very brief answer. 1.8. What is the ratio of the Population growth (in %) of Other small states in 1997 to that in 2000?
Give a very brief answer. 1.07. What is the ratio of the Population growth (in %) in Morocco in 1997 to that in 2000?
Your response must be concise. 1.15. What is the ratio of the Population growth (in %) of West Bank and Gaza in 1997 to that in 2000?
Provide a succinct answer. 1.8. What is the ratio of the Population growth (in %) in Other small states in 1997 to that in 2001?
Your answer should be very brief. 1.09. What is the ratio of the Population growth (in %) in Morocco in 1997 to that in 2001?
Offer a very short reply. 1.21. What is the ratio of the Population growth (in %) of Poland in 1997 to that in 2001?
Your response must be concise. 3.06. What is the ratio of the Population growth (in %) of West Bank and Gaza in 1997 to that in 2001?
Ensure brevity in your answer.  1.8. What is the ratio of the Population growth (in %) in Other small states in 1997 to that in 2002?
Ensure brevity in your answer.  1.12. What is the ratio of the Population growth (in %) of Morocco in 1997 to that in 2002?
Keep it short and to the point. 1.26. What is the ratio of the Population growth (in %) in West Bank and Gaza in 1997 to that in 2002?
Your answer should be compact. 1.8. What is the ratio of the Population growth (in %) of Other small states in 1998 to that in 1999?
Provide a short and direct response. 1.01. What is the ratio of the Population growth (in %) in Morocco in 1998 to that in 1999?
Your answer should be very brief. 1.05. What is the ratio of the Population growth (in %) in Poland in 1998 to that in 1999?
Provide a succinct answer. 1.66. What is the ratio of the Population growth (in %) of West Bank and Gaza in 1998 to that in 1999?
Offer a terse response. 1.06. What is the ratio of the Population growth (in %) of Other small states in 1998 to that in 2000?
Provide a short and direct response. 1.04. What is the ratio of the Population growth (in %) of Morocco in 1998 to that in 2000?
Give a very brief answer. 1.1. What is the ratio of the Population growth (in %) of West Bank and Gaza in 1998 to that in 2000?
Make the answer very short. 1.06. What is the ratio of the Population growth (in %) of Other small states in 1998 to that in 2001?
Offer a very short reply. 1.06. What is the ratio of the Population growth (in %) of Morocco in 1998 to that in 2001?
Offer a very short reply. 1.16. What is the ratio of the Population growth (in %) in Poland in 1998 to that in 2001?
Your response must be concise. 2.37. What is the ratio of the Population growth (in %) of West Bank and Gaza in 1998 to that in 2001?
Provide a succinct answer. 1.06. What is the ratio of the Population growth (in %) of Other small states in 1998 to that in 2002?
Your answer should be compact. 1.09. What is the ratio of the Population growth (in %) in Morocco in 1998 to that in 2002?
Your answer should be very brief. 1.2. What is the ratio of the Population growth (in %) of West Bank and Gaza in 1998 to that in 2002?
Keep it short and to the point. 1.06. What is the ratio of the Population growth (in %) in Other small states in 1999 to that in 2000?
Make the answer very short. 1.03. What is the ratio of the Population growth (in %) in Morocco in 1999 to that in 2000?
Keep it short and to the point. 1.05. What is the ratio of the Population growth (in %) of West Bank and Gaza in 1999 to that in 2000?
Give a very brief answer. 1. What is the ratio of the Population growth (in %) of Other small states in 1999 to that in 2001?
Ensure brevity in your answer.  1.05. What is the ratio of the Population growth (in %) of Morocco in 1999 to that in 2001?
Offer a very short reply. 1.1. What is the ratio of the Population growth (in %) in Poland in 1999 to that in 2001?
Provide a short and direct response. 1.43. What is the ratio of the Population growth (in %) in West Bank and Gaza in 1999 to that in 2001?
Your answer should be compact. 1. What is the ratio of the Population growth (in %) of Other small states in 1999 to that in 2002?
Provide a succinct answer. 1.08. What is the ratio of the Population growth (in %) in Morocco in 1999 to that in 2002?
Your response must be concise. 1.15. What is the ratio of the Population growth (in %) in West Bank and Gaza in 1999 to that in 2002?
Keep it short and to the point. 1. What is the ratio of the Population growth (in %) in Other small states in 2000 to that in 2001?
Make the answer very short. 1.02. What is the ratio of the Population growth (in %) of Morocco in 2000 to that in 2001?
Your answer should be very brief. 1.05. What is the ratio of the Population growth (in %) in Other small states in 2000 to that in 2002?
Ensure brevity in your answer.  1.05. What is the ratio of the Population growth (in %) in Morocco in 2000 to that in 2002?
Your answer should be very brief. 1.09. What is the ratio of the Population growth (in %) in West Bank and Gaza in 2000 to that in 2002?
Ensure brevity in your answer.  1. What is the ratio of the Population growth (in %) of Other small states in 2001 to that in 2002?
Your answer should be very brief. 1.03. What is the ratio of the Population growth (in %) in Morocco in 2001 to that in 2002?
Keep it short and to the point. 1.04. What is the difference between the highest and the second highest Population growth (in %) of Other small states?
Provide a succinct answer. 0.05. What is the difference between the highest and the second highest Population growth (in %) in Morocco?
Make the answer very short. 0.23. What is the difference between the highest and the second highest Population growth (in %) in Poland?
Make the answer very short. 0.06. What is the difference between the highest and the second highest Population growth (in %) of West Bank and Gaza?
Your answer should be compact. 0.01. What is the difference between the highest and the lowest Population growth (in %) of Other small states?
Ensure brevity in your answer.  0.54. What is the difference between the highest and the lowest Population growth (in %) of Morocco?
Offer a very short reply. 0.73. What is the difference between the highest and the lowest Population growth (in %) of Poland?
Ensure brevity in your answer.  0.21. What is the difference between the highest and the lowest Population growth (in %) in West Bank and Gaza?
Provide a short and direct response. 2.32. 